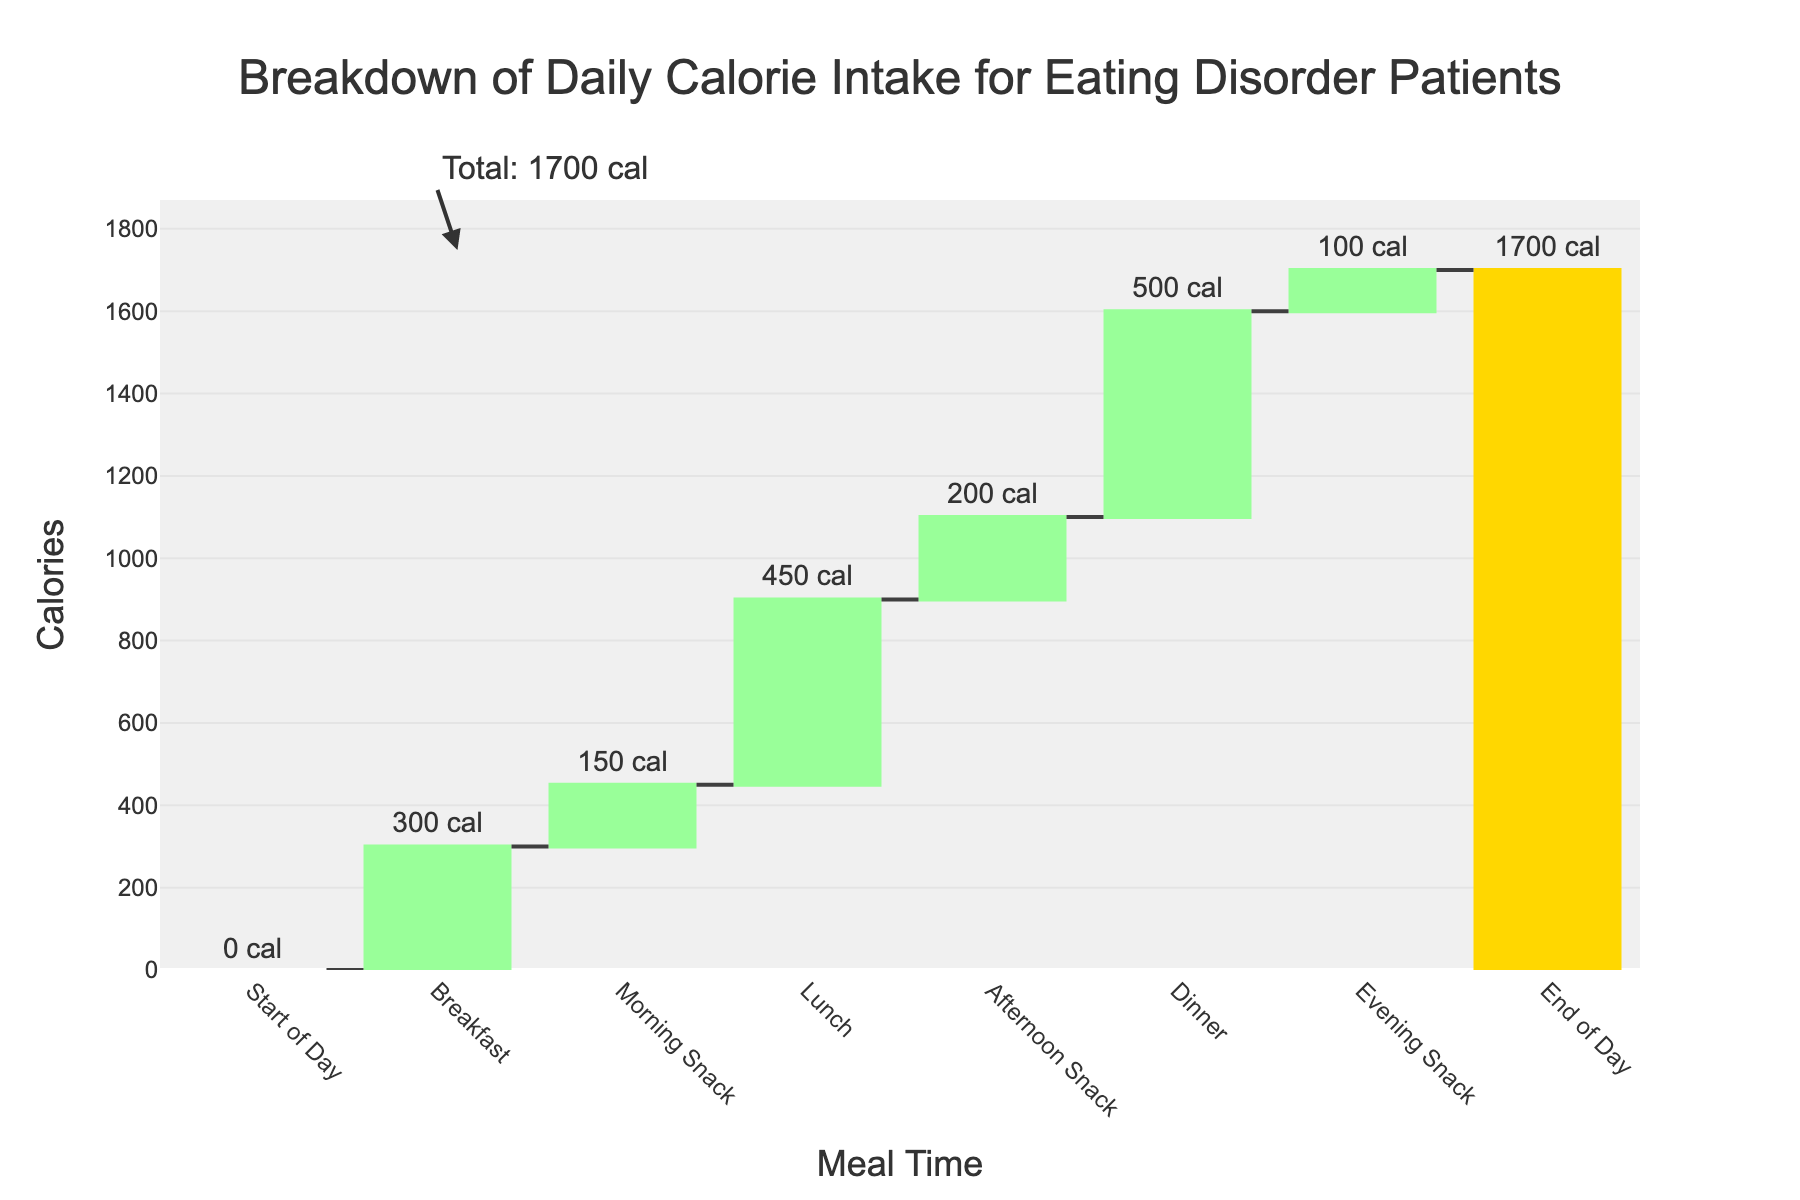What is the total calorie intake by the end of the day? The total calorie intake is indicated by the final bar labeled "End of Day". This value is shown as the total for the day.
Answer: 1700 cal What meal has the highest calorie intake? By observing the heights of the bars in the waterfall chart, the bar for "Dinner" has the highest value, indicating the highest calorie intake.
Answer: Dinner What are the calorie intakes for lunch and afternoon snack combined? The chart shows "Lunch" with 450 calories and "Afternoon Snack" with 200 calories. Adding these together gives 450 + 200.
Answer: 650 cal Which time period had the lowest calorie intake? By comparing the heights of all the bars, the "Evening Snack" has the shortest bar, indicating it has the lowest calorie intake.
Answer: Evening Snack How much more calories are consumed at breakfast compared to the morning snack? The chart shows "Breakfast" at 300 calories and "Morning Snack" at 150 calories. The difference is 300 - 150.
Answer: 150 cal What is the increase in calories from the morning snack to lunch? "Morning Snack" has 150 calories and "Lunch" has 450 calories. The increase is 450 - 150.
Answer: 300 cal What is the calorie intake between breakfast and lunch? Summing "Breakfast" (300 cal), "Morning Snack" (150 cal), and "Lunch" (450 cal) gives 300 + 150 + 450.
Answer: 900 cal Does the calorie intake for dinner exceed the combined intake of morning and afternoon snacks? "Dinner" has 500 calories. Morning snack is 150 calories, and afternoon snack is 200 calories. The combined intake for the snacks is 150 + 200 = 350, which is less than 500.
Answer: Yes How much more calories are consumed in the afternoon snack compared to the evening snack? "Afternoon Snack" is 200 calories and "Evening Snack" is 100 calories. The difference is 200 - 100.
Answer: 100 cal What is the percentage of total daily calories consumed by lunch? "Lunch" has 450 calories, and the total daily calories are 1700. The percentage is (450 / 1700) * 100%.
Answer: 26.47% 